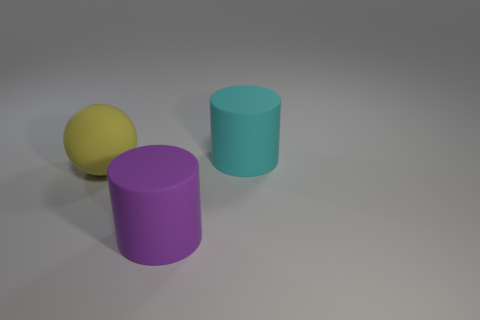There is a yellow thing behind the big matte object that is in front of the sphere; are there any yellow spheres to the right of it?
Ensure brevity in your answer.  No. Is there anything else that is the same shape as the big yellow object?
Offer a very short reply. No. There is a large matte object that is both in front of the big cyan matte cylinder and on the right side of the yellow matte object; what color is it?
Your response must be concise. Purple. Are there any purple cylinders that are behind the object left of the large purple object?
Keep it short and to the point. No. There is a matte ball; are there any large rubber objects behind it?
Provide a short and direct response. Yes. Is the number of large purple rubber things behind the large purple thing the same as the number of matte cylinders that are on the left side of the big cyan cylinder?
Your response must be concise. No. What number of large cyan rubber cylinders are there?
Provide a short and direct response. 1. Is the number of spheres that are in front of the large cyan rubber thing greater than the number of large brown matte blocks?
Your answer should be very brief. Yes. What color is the other rubber object that is the same shape as the purple matte object?
Offer a very short reply. Cyan. There is a rubber cylinder in front of the cyan cylinder; does it have the same size as the cylinder that is to the right of the purple cylinder?
Provide a short and direct response. Yes. 